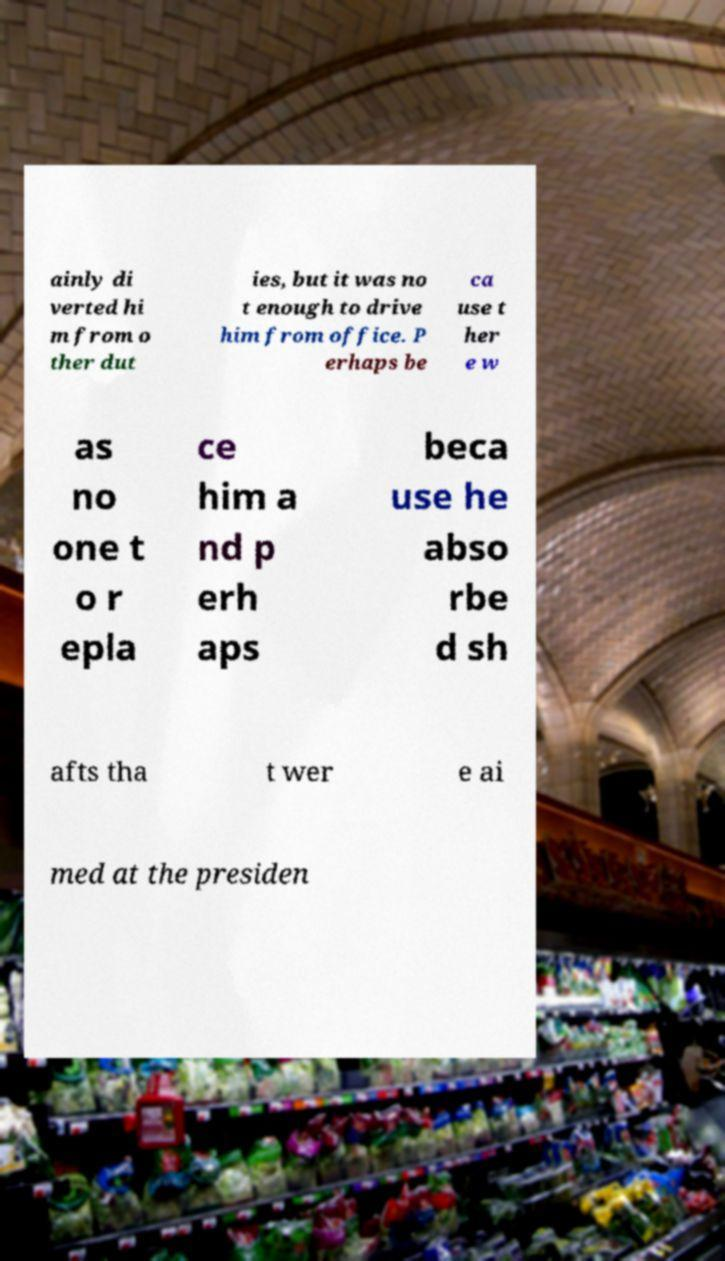Could you assist in decoding the text presented in this image and type it out clearly? ainly di verted hi m from o ther dut ies, but it was no t enough to drive him from office. P erhaps be ca use t her e w as no one t o r epla ce him a nd p erh aps beca use he abso rbe d sh afts tha t wer e ai med at the presiden 